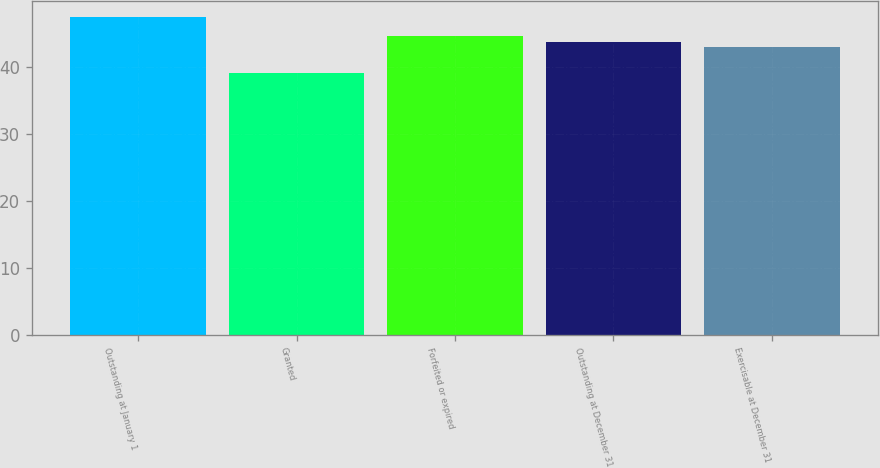<chart> <loc_0><loc_0><loc_500><loc_500><bar_chart><fcel>Outstanding at January 1<fcel>Granted<fcel>Forfeited or expired<fcel>Outstanding at December 31<fcel>Exercisable at December 31<nl><fcel>47.51<fcel>39.18<fcel>44.65<fcel>43.82<fcel>42.99<nl></chart> 